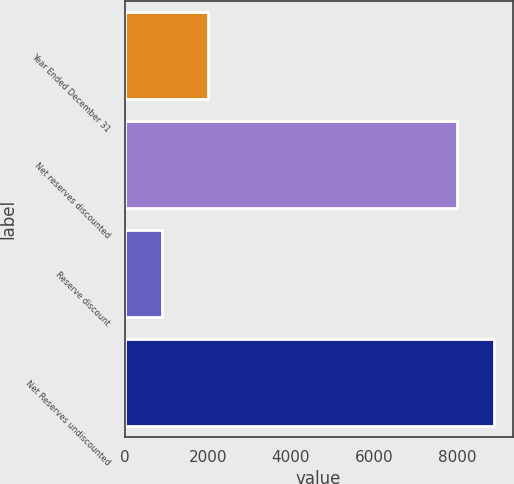Convert chart. <chart><loc_0><loc_0><loc_500><loc_500><bar_chart><fcel>Year Ended December 31<fcel>Net reserves discounted<fcel>Reserve discount<fcel>Net Reserves undiscounted<nl><fcel>2010<fcel>8000<fcel>898<fcel>8898<nl></chart> 